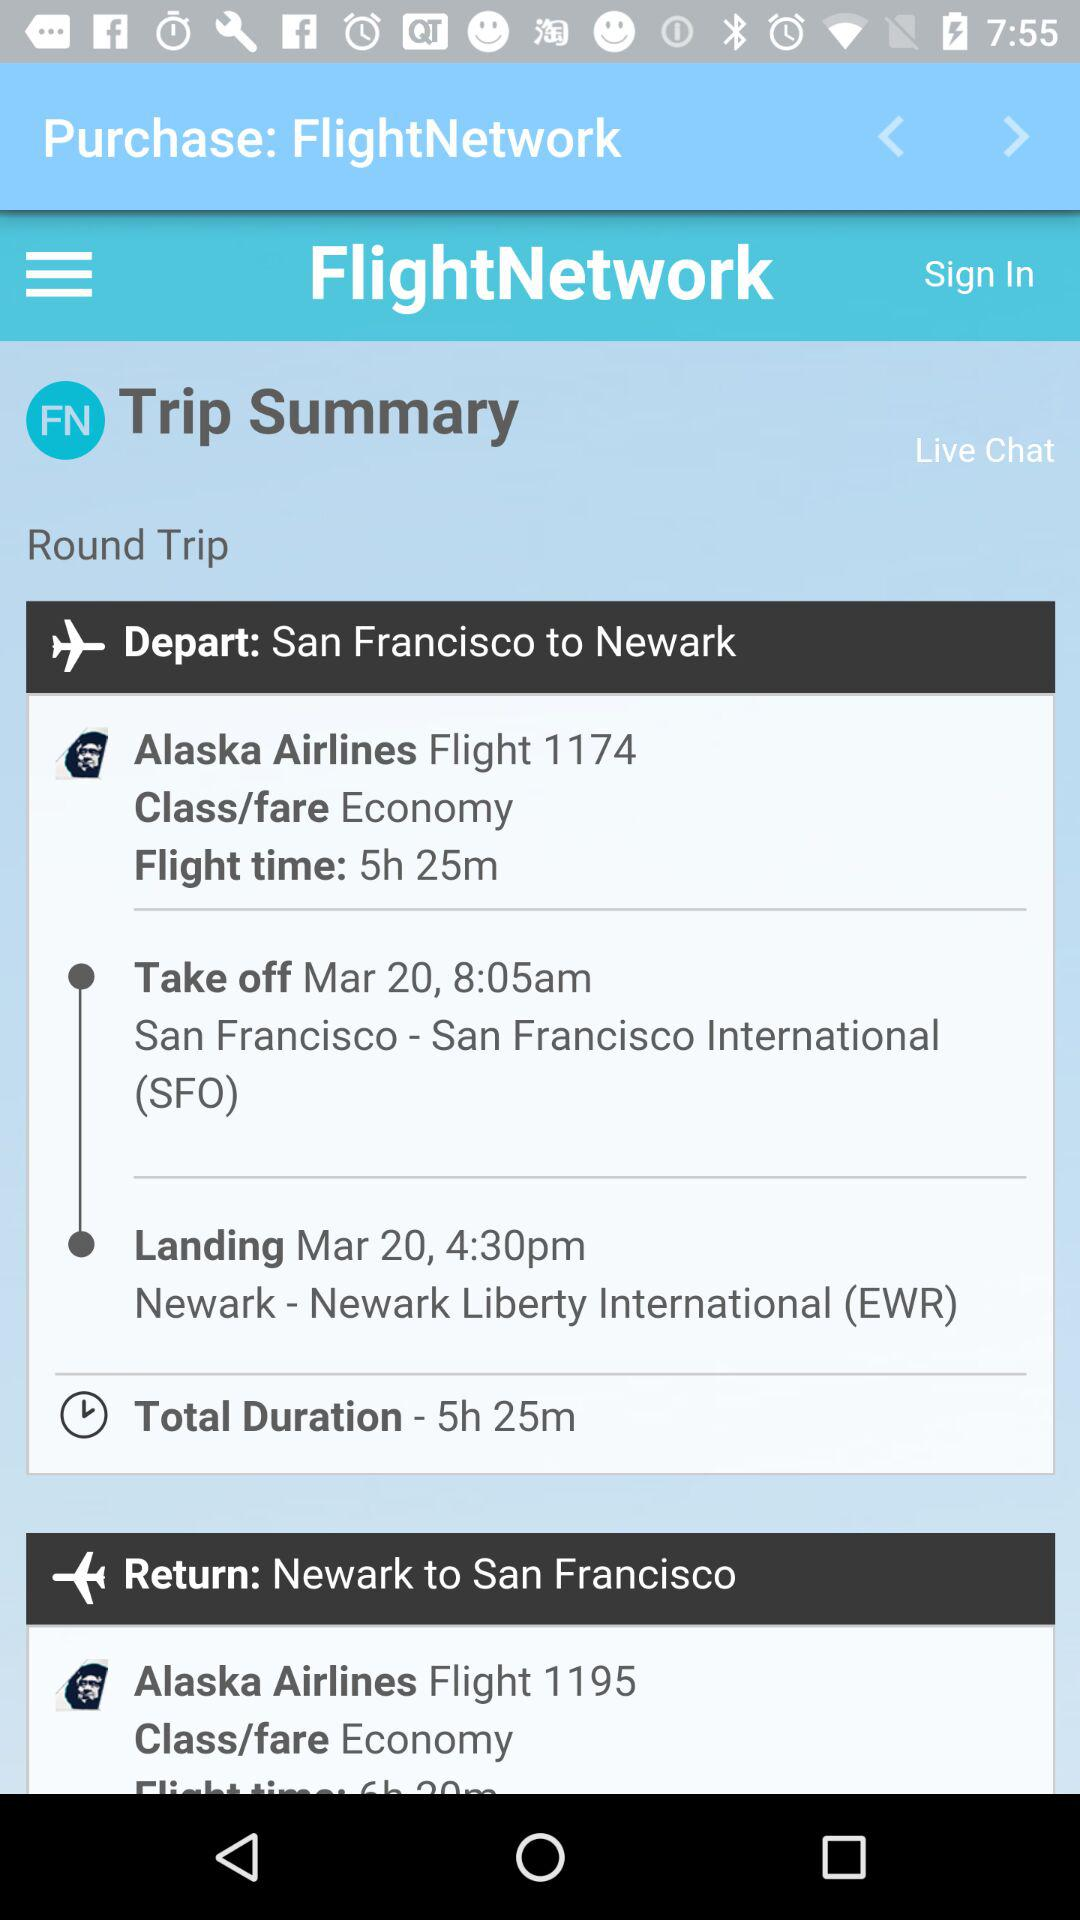What is the name of the application? The name of the application is "FlightNetwork". 